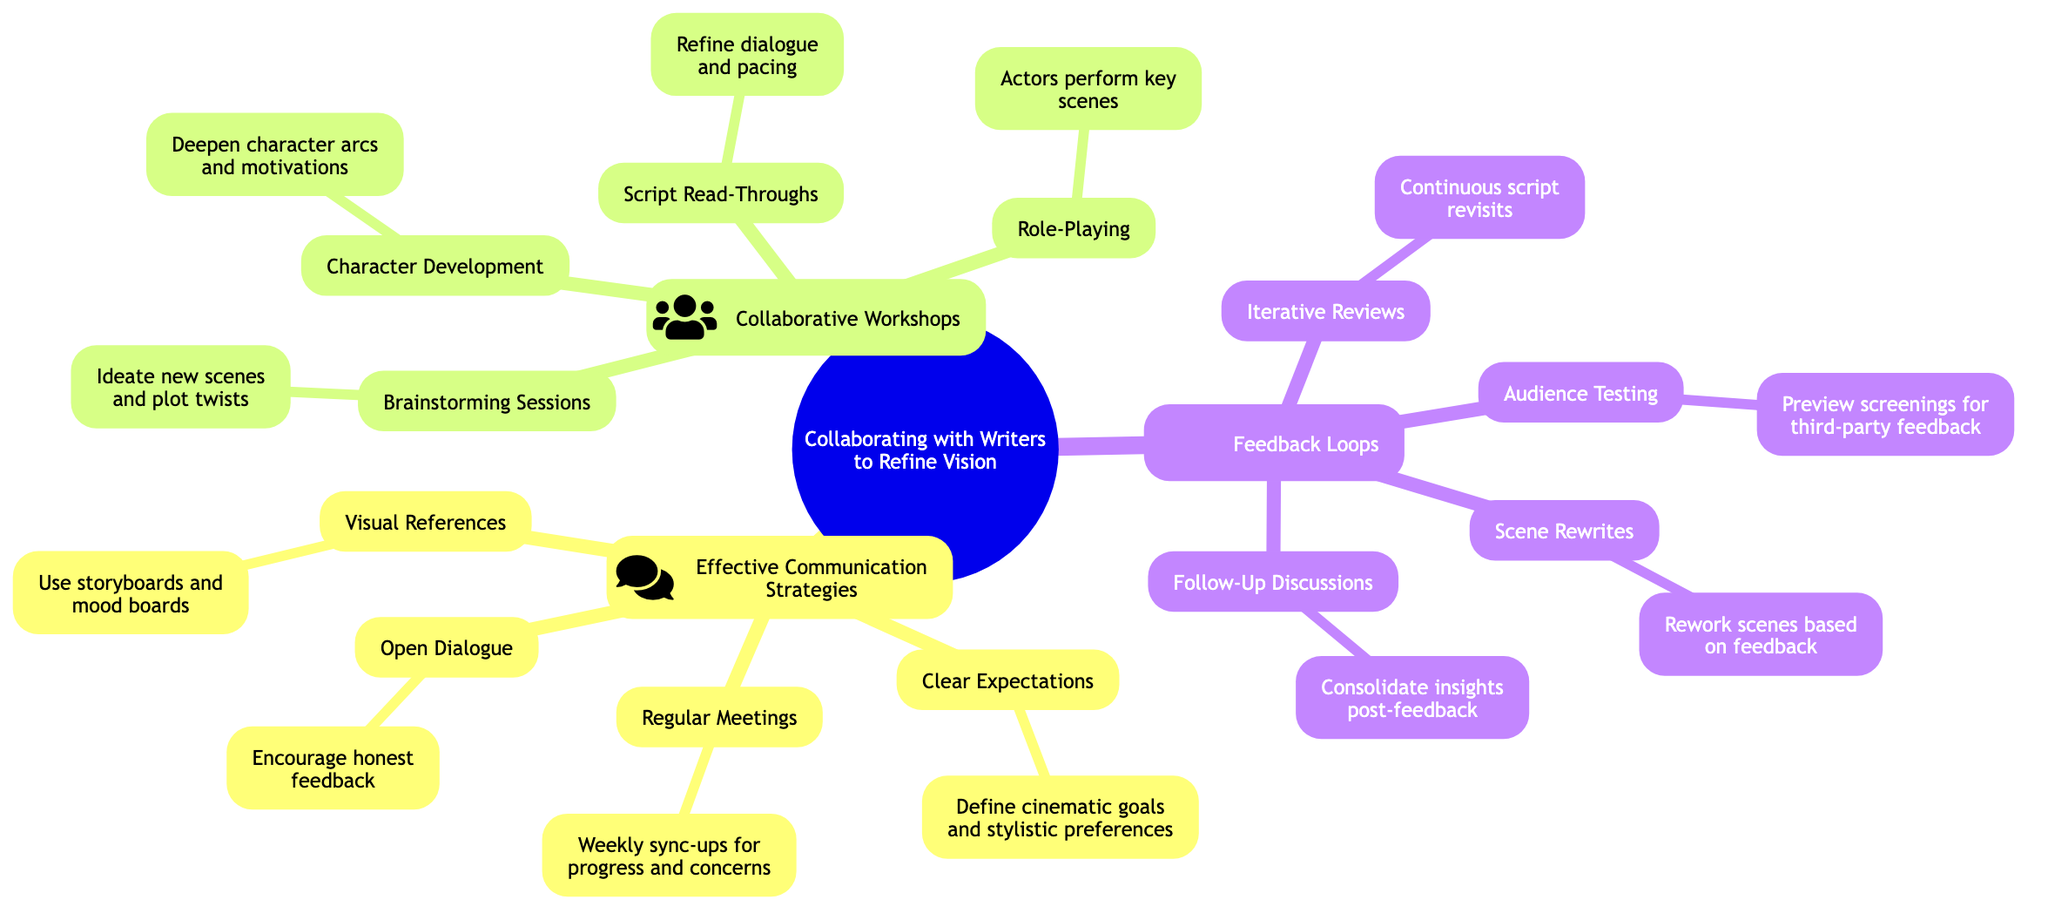What is the primary focus of the mind map? The central node is titled "Collaborating with Writers to Refine Vision," indicating that this is the main theme of the diagram.
Answer: Collaborating with Writers to Refine Vision How many main strategies are listed under the mind map? There are three primary sections: "Effective Communication Strategies," "Collaborative Workshops," and "Feedback Loops," which makes a total of three.
Answer: 3 What does "Clear Expectations" refer to in the context of the diagram? "Clear Expectations" under "Effective Communication Strategies" refers to defining cinematic goals and stylistic preferences early on, which is crucial for clarity in collaboration.
Answer: Define cinematic goals and stylistic preferences What type of events are included in "Collaborative Workshops"? The section "Collaborative Workshops" includes events such as "Brainstorming Sessions," "Script Read-Throughs," "Character Development," and "Role-Playing," which emphasize teamwork and joint effort in refining the vision.
Answer: Brainstorming Sessions, Script Read-Throughs, Character Development, Role-Playing What is the purpose of "Audience Testing" in the feedback loop? "Audience Testing" is listed under "Feedback Loops" and is intended to gather third-party feedback through preview screenings, helping the team understand how their work resonates with viewers.
Answer: Preview screenings for third-party feedback How do "Iterative Reviews" contribute to the writing process? "Iterative Reviews," included in "Feedback Loops," emphasize the need for continuous script revisits to implement and test changes, facilitating an ongoing refinement process throughout the writing.
Answer: Continuous script revisits What role does "Role-Playing" serve in "Collaborative Workshops"? "Role-Playing," mentioned under "Collaborative Workshops," allows actors and writers to perform key scenes, helping explore dynamics and deepen understanding of character interplay, which enriches the script.
Answer: Actors perform key scenes How is feedback intended to be utilized according to "Follow-Up Discussions"? "Follow-Up Discussions" aim to consolidate insights gained during the feedback process, ensuring that all team members understand the feedback and can implement it effectively in the script.
Answer: Consolidate insights post-feedback 